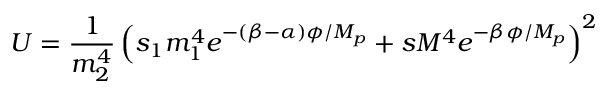<formula> <loc_0><loc_0><loc_500><loc_500>U = \frac { 1 } { m _ { 2 } ^ { 4 } } \left ( s _ { 1 } m _ { 1 } ^ { 4 } e ^ { - ( \beta - \alpha ) \phi / M _ { p } } + s M ^ { 4 } e ^ { - \beta \phi / M _ { p } } \right ) ^ { 2 }</formula> 